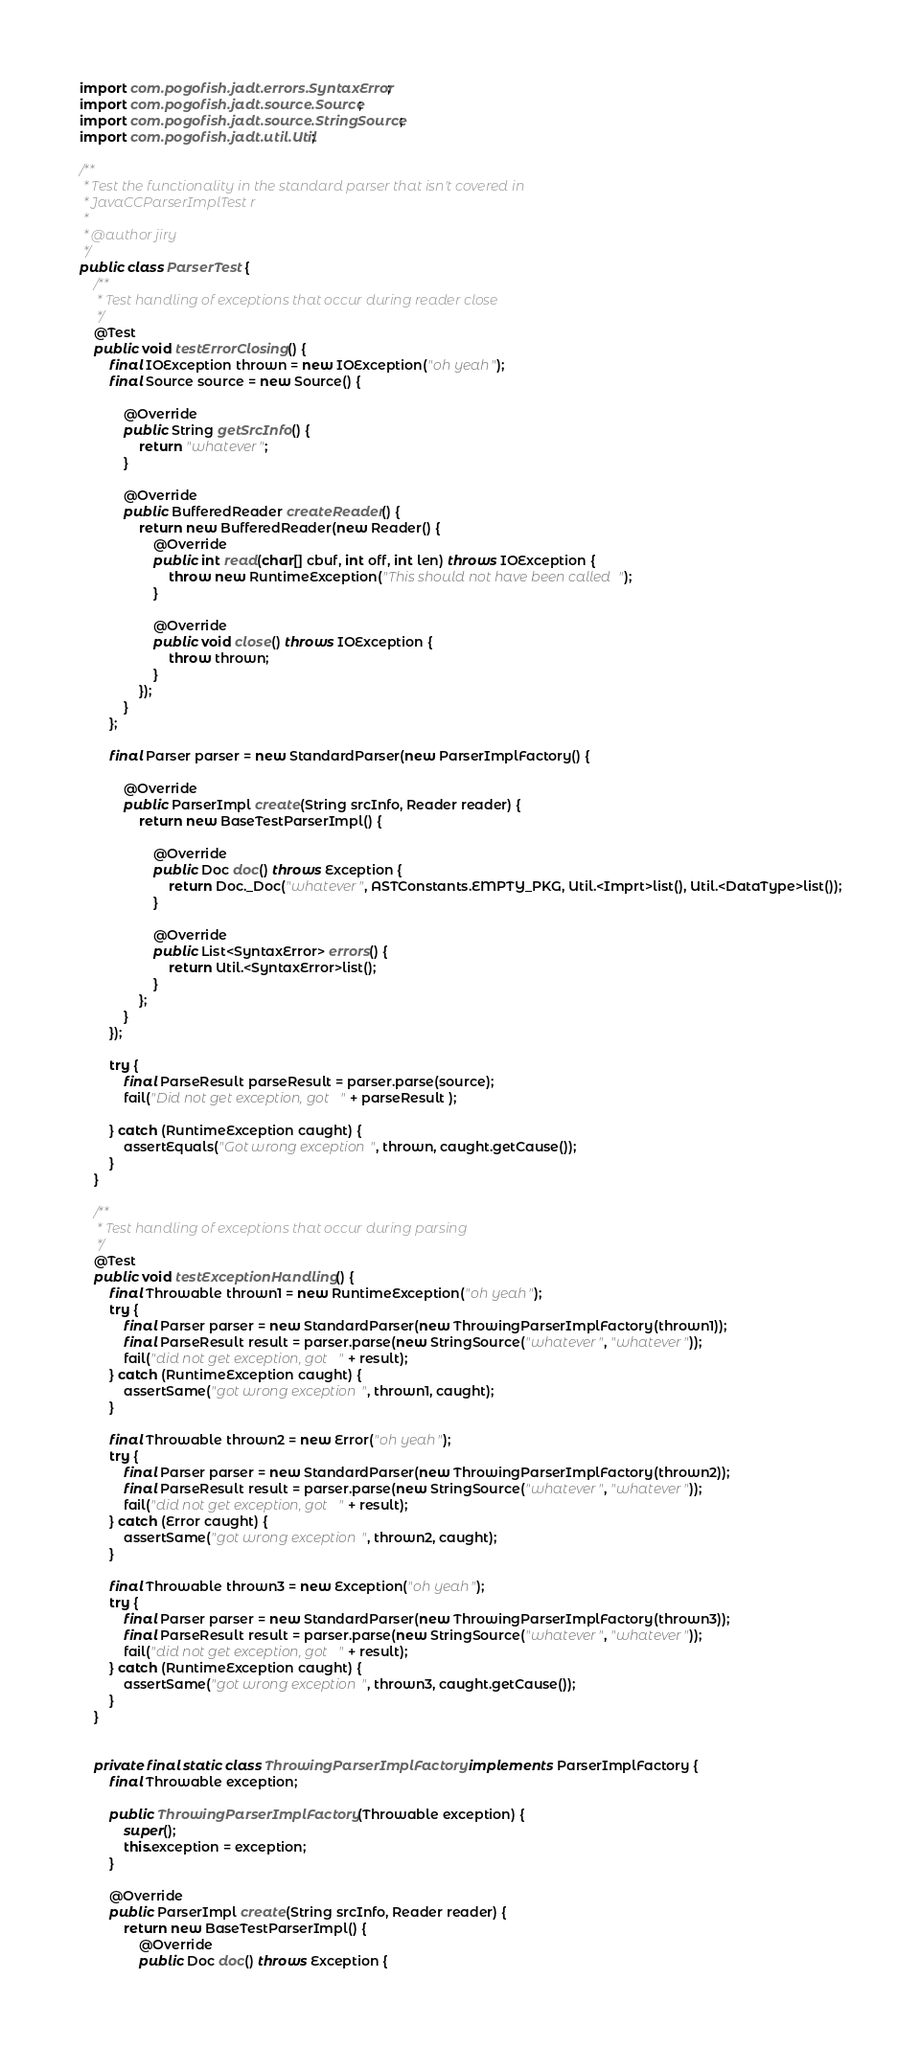<code> <loc_0><loc_0><loc_500><loc_500><_Java_>import com.pogofish.jadt.errors.SyntaxError;
import com.pogofish.jadt.source.Source;
import com.pogofish.jadt.source.StringSource;
import com.pogofish.jadt.util.Util;

/**
 * Test the functionality in the standard parser that isn't covered in
 * JavaCCParserImplTest r
 * 
 * @author jiry
 */
public class ParserTest {
    /**
     * Test handling of exceptions that occur during reader close
     */
    @Test
    public void testErrorClosing() {
        final IOException thrown = new IOException("oh yeah");
        final Source source = new Source() {
            
            @Override
            public String getSrcInfo() {
                return "whatever";
            }
            
            @Override
            public BufferedReader createReader() {
                return new BufferedReader(new Reader() { 
                    @Override
                    public int read(char[] cbuf, int off, int len) throws IOException {
                        throw new RuntimeException("This should not have been called");
                    }
                    
                    @Override
                    public void close() throws IOException {
                        throw thrown;
                    }
                });
            }
        };
        
        final Parser parser = new StandardParser(new ParserImplFactory() {
            
            @Override
            public ParserImpl create(String srcInfo, Reader reader) {
                return new BaseTestParserImpl() {
                    
                    @Override
                    public Doc doc() throws Exception {
                        return Doc._Doc("whatever", ASTConstants.EMPTY_PKG, Util.<Imprt>list(), Util.<DataType>list());
                    }

                    @Override
                    public List<SyntaxError> errors() {
                        return Util.<SyntaxError>list();
                    }
                };
            }
        });
        
        try {
            final ParseResult parseResult = parser.parse(source);
            fail("Did not get exception, got " + parseResult );
            
        } catch (RuntimeException caught) {
            assertEquals("Got wrong exception", thrown, caught.getCause());
        }
    }
    
    /**
     * Test handling of exceptions that occur during parsing
     */
    @Test
    public void testExceptionHandling() {
        final Throwable thrown1 = new RuntimeException("oh yeah");
        try {
            final Parser parser = new StandardParser(new ThrowingParserImplFactory(thrown1));
            final ParseResult result = parser.parse(new StringSource("whatever", "whatever"));
            fail("did not get exception, got " + result);
        } catch (RuntimeException caught) {
            assertSame("got wrong exception", thrown1, caught);
        }
        
        final Throwable thrown2 = new Error("oh yeah");
        try {
            final Parser parser = new StandardParser(new ThrowingParserImplFactory(thrown2));
            final ParseResult result = parser.parse(new StringSource("whatever", "whatever"));
            fail("did not get exception, got " + result);
        } catch (Error caught) {
            assertSame("got wrong exception", thrown2, caught);
        }
        
        final Throwable thrown3 = new Exception("oh yeah");
        try {
            final Parser parser = new StandardParser(new ThrowingParserImplFactory(thrown3));
            final ParseResult result = parser.parse(new StringSource("whatever", "whatever"));
            fail("did not get exception, got " + result);
        } catch (RuntimeException caught) {
            assertSame("got wrong exception", thrown3, caught.getCause());
        }
    }

    
    private final static class ThrowingParserImplFactory implements ParserImplFactory {
        final Throwable exception;

        public ThrowingParserImplFactory(Throwable exception) {
            super();
            this.exception = exception;
        }

        @Override
        public ParserImpl create(String srcInfo, Reader reader) {
            return new BaseTestParserImpl() {
                @Override
                public Doc doc() throws Exception {</code> 